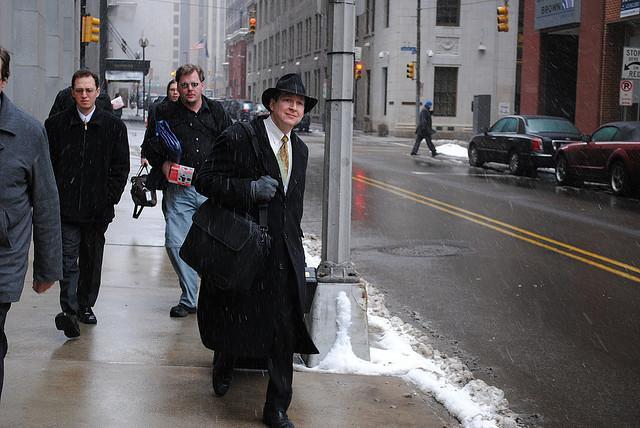How many people are in the picture?
Give a very brief answer. 4. How many cars are there?
Give a very brief answer. 2. 